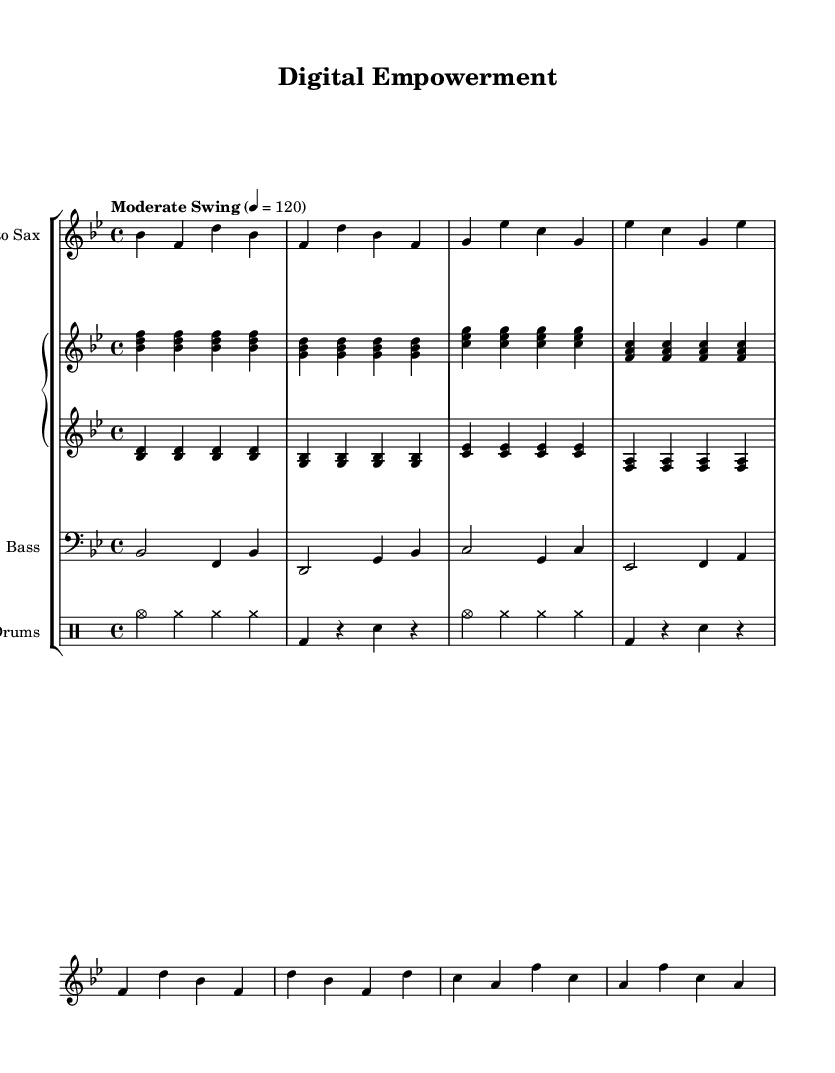What is the key signature of this music? The key signature is B flat major, which contains two flats: B flat and E flat. This can be determined by looking at the key signature at the beginning of the staff, which shows these two flats.
Answer: B flat major What is the time signature of this piece? The time signature is 4/4, which is indicated at the beginning of the score next to the key signature. This means there are four beats in each measure, and the quarter note gets one beat.
Answer: 4/4 What is the tempo marking for this composition? The tempo marking is "Moderate Swing", noted in the score and indicating a specific jazz feel and swing rhythm, along with a beats-per-minute value of 120.
Answer: Moderate Swing Which instrument has the melody in this piece? The melody is primarily carried by the alto saxophone, as indicated by the notation associated with the saxophone music staff in the score, showing the melodic line.
Answer: Alto Saxophone How many measures are in the saxophone part? There are eight measures in the saxophone music section. Each measure is delineated by vertical bar lines, and counting from the beginning to the end reveals a total of eight distinct measures.
Answer: Eight What type of chord progression is primarily used in the piano right hand? The piano right hand predominantly uses triads throughout, as seen in the groupings of three notes that make up each chord notated in the staff. This harmonic structure is typical of jazz compositions.
Answer: Triads What feature in the drum part indicates a swing style? The use of cymbal crashes and the rhythmic pattern suggest a swing style, which is characteristic of jazz drumming. Specifically, the notation of "cym" (cymbal hits) in combination with other rhythmic elements reflects the upbeat nature common in jazz drumming.
Answer: Swing style 